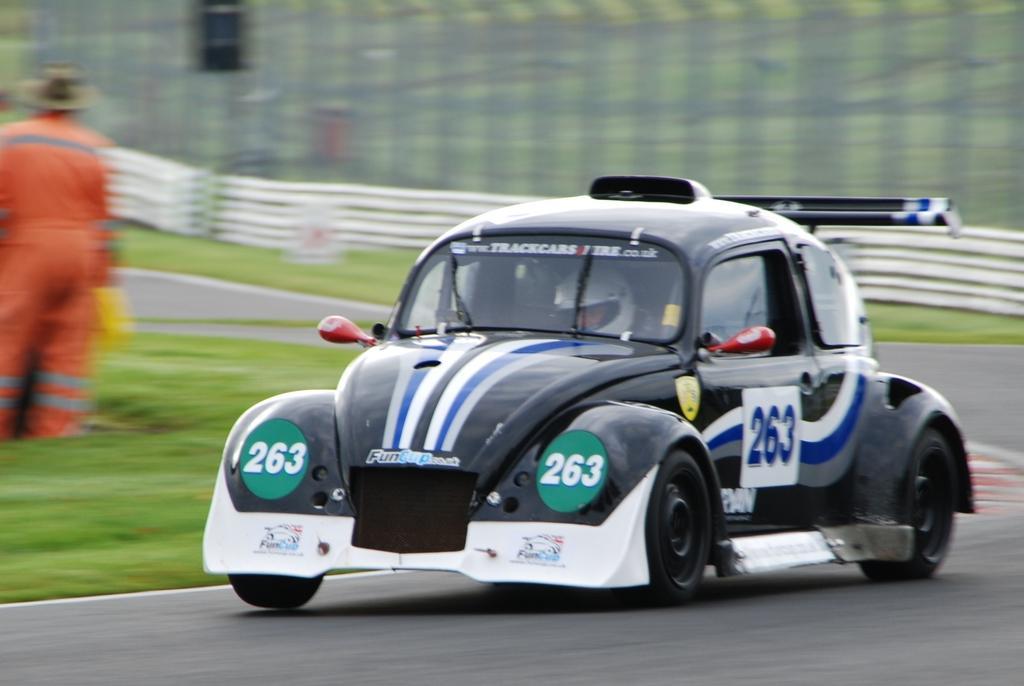Could you give a brief overview of what you see in this image? This car is travelling on road. Far this person is standing. Inside this car a person is sitting and wore helmet. 